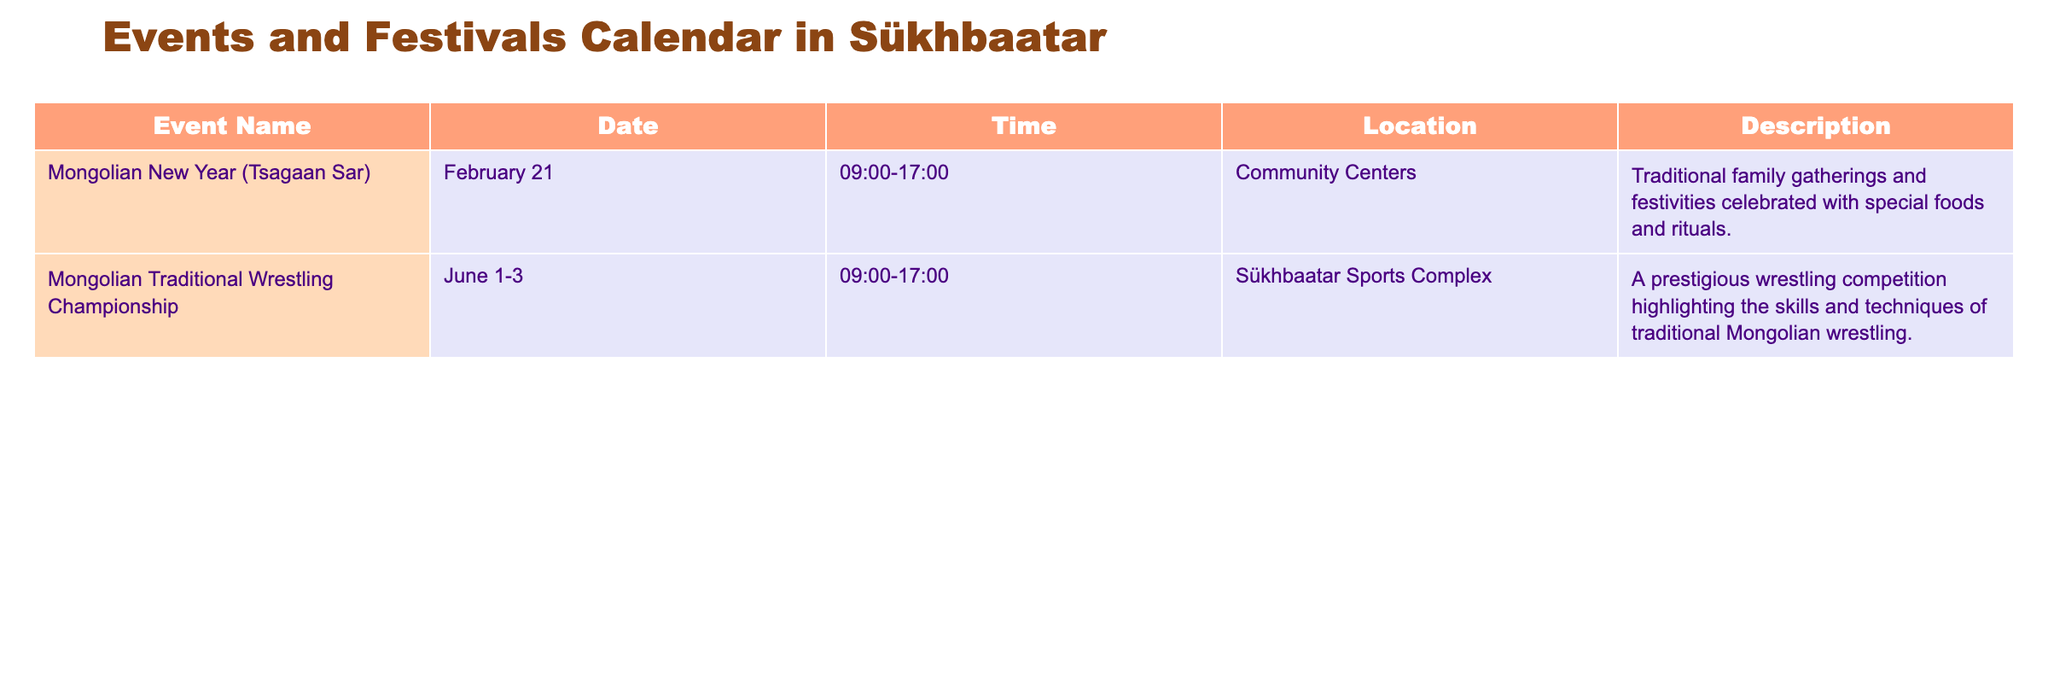What is the date of the Mongolian New Year (Tsagaan Sar)? The table specifies that the Mongolian New Year (Tsagaan Sar) is on February 21.
Answer: February 21 How long does the Mongolian Traditional Wrestling Championship last? The event spans from June 1 to June 3, which is a total of three days.
Answer: Three days What time do events start and end on February 21? The timetable indicates that events on February 21 start at 09:00 and end at 17:00, making the duration 8 hours.
Answer: 09:00 to 17:00 Is there an event related to wrestling happening in Sükhbaatar? Yes, the Mongolian Traditional Wrestling Championship is scheduled at the Sükhbaatar Sports Complex.
Answer: Yes How many events are listed for February? There is only one event listed for February, which is the Mongolian New Year (Tsagaan Sar).
Answer: One event Which event is held in the Sükhbaatar Sports Complex? The only event listed at the Sükhbaatar Sports Complex is the Mongolian Traditional Wrestling Championship.
Answer: Mongolian Traditional Wrestling Championship What is the total number of events happening in June? Only one event is recorded for June, the Mongolian Traditional Wrestling Championship, covering three days.
Answer: One event Does the Mongolian New Year (Tsagaan Sar) involve traditional family gatherings? Yes, it is specifically described as traditional family gatherings and festivities celebrated with special foods and rituals.
Answer: Yes Which month has more than one event listed? Based on the data provided, neither month has more than one event; both events occur in February and June respectively, so the answer is no months have multiple events.
Answer: No months have multiple events 